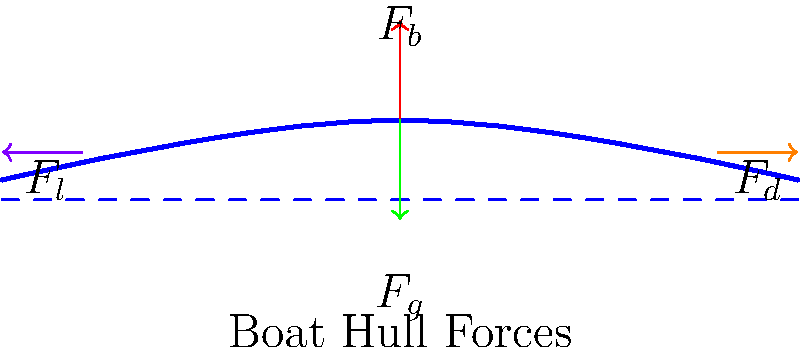As a marine equipment distributor, you often encounter questions about the forces acting on boat hulls. Consider the diagram showing a boat hull in various sea conditions. Which of the following forces is primarily responsible for counteracting the boat's weight and keeping it afloat?

A) $F_d$ (Drag force)
B) $F_b$ (Buoyant force)
C) $F_l$ (Lift force)
D) $F_g$ (Gravitational force) To understand the forces acting on a boat hull, let's break down the diagram and analyze each force:

1. $F_g$ (Gravitational force): This is the downward force due to the boat's weight, acting at the center of mass.

2. $F_b$ (Buoyant force): This upward force is exerted by the water on the hull, following Archimedes' principle. It's equal to the weight of the water displaced by the hull.

3. $F_d$ (Drag force): This horizontal force opposes the boat's motion through the water, caused by friction and pressure differences.

4. $F_l$ (Lift force): This is a hydrodynamic force that can occur when the hull is moving, potentially lifting the boat slightly out of the water.

The primary force responsible for keeping the boat afloat is the buoyant force ($F_b$). This follows from Archimedes' principle, which states that the upward buoyant force exerted on a body immersed in a fluid is equal to the weight of the fluid displaced by the body.

For a boat to float, the buoyant force must be equal to the gravitational force:

$$ F_b = F_g $$

When this equilibrium is maintained, the boat remains afloat. If $F_b$ were less than $F_g$, the boat would sink. The other forces ($F_d$ and $F_l$) primarily affect the boat's motion through the water but do not directly contribute to keeping it afloat.
Answer: B) $F_b$ (Buoyant force) 